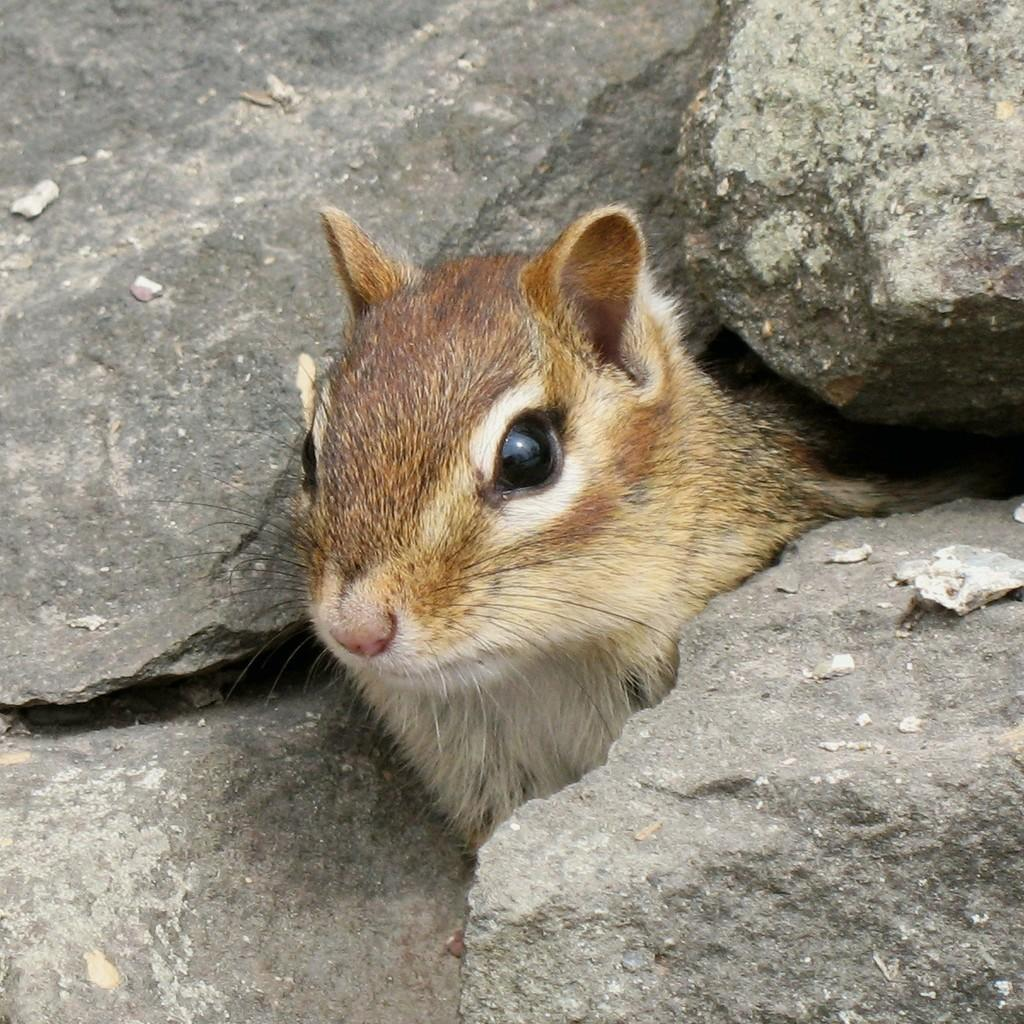What is the main subject in the center of the image? There is an animal in the center of the image. What can be seen in the background of the image? There are rocks visible in the background of the image. What type of plastic is covering the animal in the image? There is no plastic covering the animal in the image; it is not mentioned in the provided facts. 